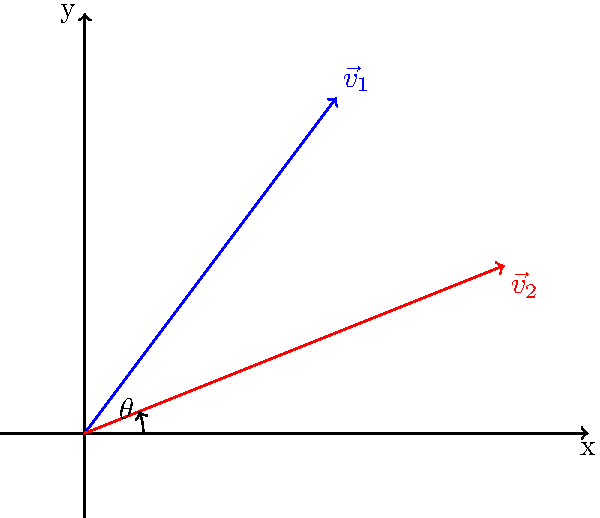As a cosplayer preparing for a photoshoot, you want to optimize the lighting angle for your costume. You have two light sources represented by vectors $\vec{v}_1 = (3,4)$ and $\vec{v}_2 = (5,2)$. To create the best lighting effect, you need to find the angle between these vectors. Calculate the angle $\theta$ between $\vec{v}_1$ and $\vec{v}_2$ using the dot product formula. To find the angle between two vectors using the dot product, we can follow these steps:

1) The dot product formula for the angle between two vectors is:

   $$\cos \theta = \frac{\vec{v}_1 \cdot \vec{v}_2}{|\vec{v}_1||\vec{v}_2|}$$

2) Calculate the dot product $\vec{v}_1 \cdot \vec{v}_2$:
   $$\vec{v}_1 \cdot \vec{v}_2 = (3 \times 5) + (4 \times 2) = 15 + 8 = 23$$

3) Calculate the magnitudes of the vectors:
   $$|\vec{v}_1| = \sqrt{3^2 + 4^2} = \sqrt{9 + 16} = \sqrt{25} = 5$$
   $$|\vec{v}_2| = \sqrt{5^2 + 2^2} = \sqrt{25 + 4} = \sqrt{29}$$

4) Substitute these values into the formula:
   $$\cos \theta = \frac{23}{5\sqrt{29}}$$

5) Take the inverse cosine (arccos) of both sides:
   $$\theta = \arccos(\frac{23}{5\sqrt{29}})$$

6) Calculate the result:
   $$\theta \approx 0.3398 \text{ radians} \approx 19.47°$$

This angle represents the optimal separation between your light sources for the best lighting effect on your cosplay costume.
Answer: $19.47°$ 